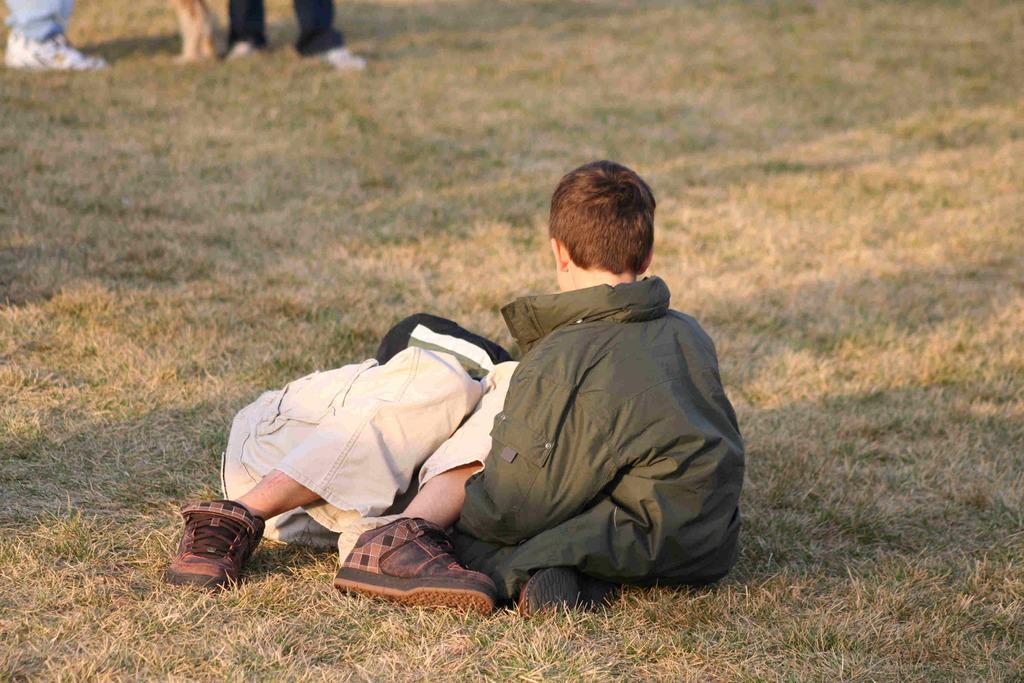How would you summarize this image in a sentence or two? In this picture there is a man who is lying on the floor in the center of the image and there is a small boy in the center of the image, there are other people at the top side of the image. 